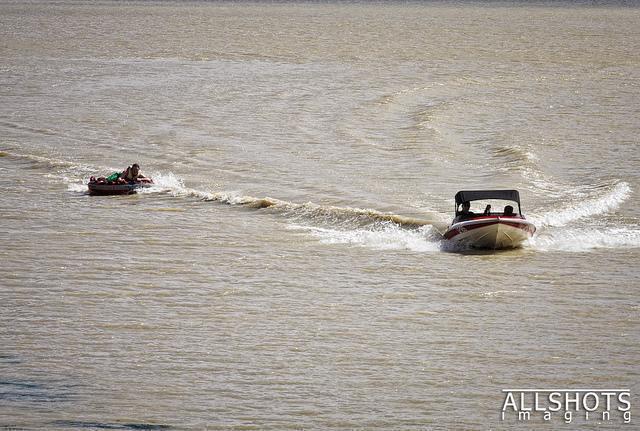How is the small vessel being moved?
Make your selection from the four choices given to correctly answer the question.
Options: Motor, sail, pushed, towed. Towed. 